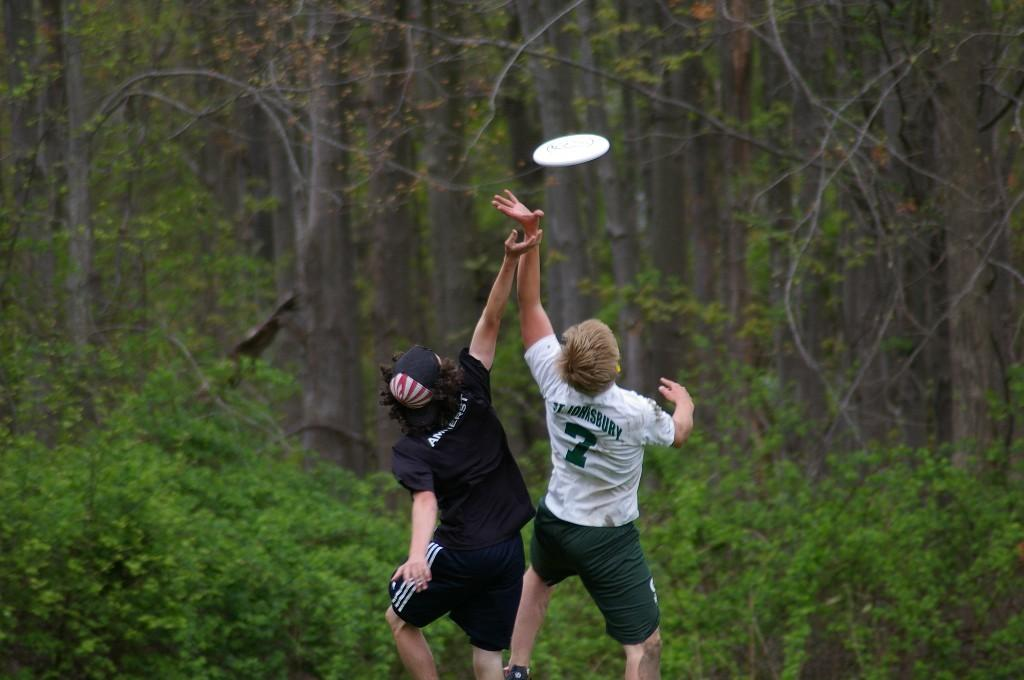How many people are in the image? There are two persons in the image. What are the two persons doing in the image? The two persons are playing a game. What is used in the game that the two persons are playing? There is an object involved in the game. What can be seen in the background of the image? Bushes and trees are visible in the image. How many books are on the table in the image? There are no books present in the image. What type of experience do the two persons have playing this game? The image does not provide information about the experience of the two persons playing the game. 